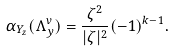Convert formula to latex. <formula><loc_0><loc_0><loc_500><loc_500>\alpha _ { Y _ { z } } ( \Lambda _ { y } ^ { v } ) = \frac { \zeta ^ { 2 } } { | \zeta | ^ { 2 } } ( - 1 ) ^ { k - 1 } .</formula> 